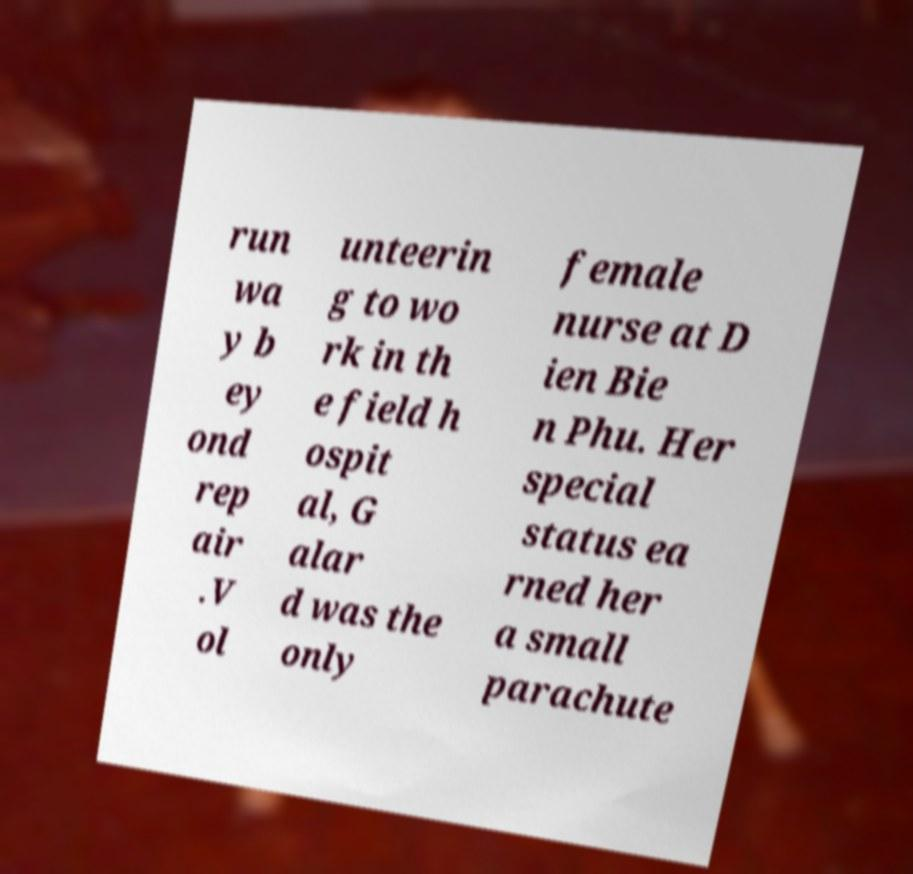Can you accurately transcribe the text from the provided image for me? run wa y b ey ond rep air .V ol unteerin g to wo rk in th e field h ospit al, G alar d was the only female nurse at D ien Bie n Phu. Her special status ea rned her a small parachute 